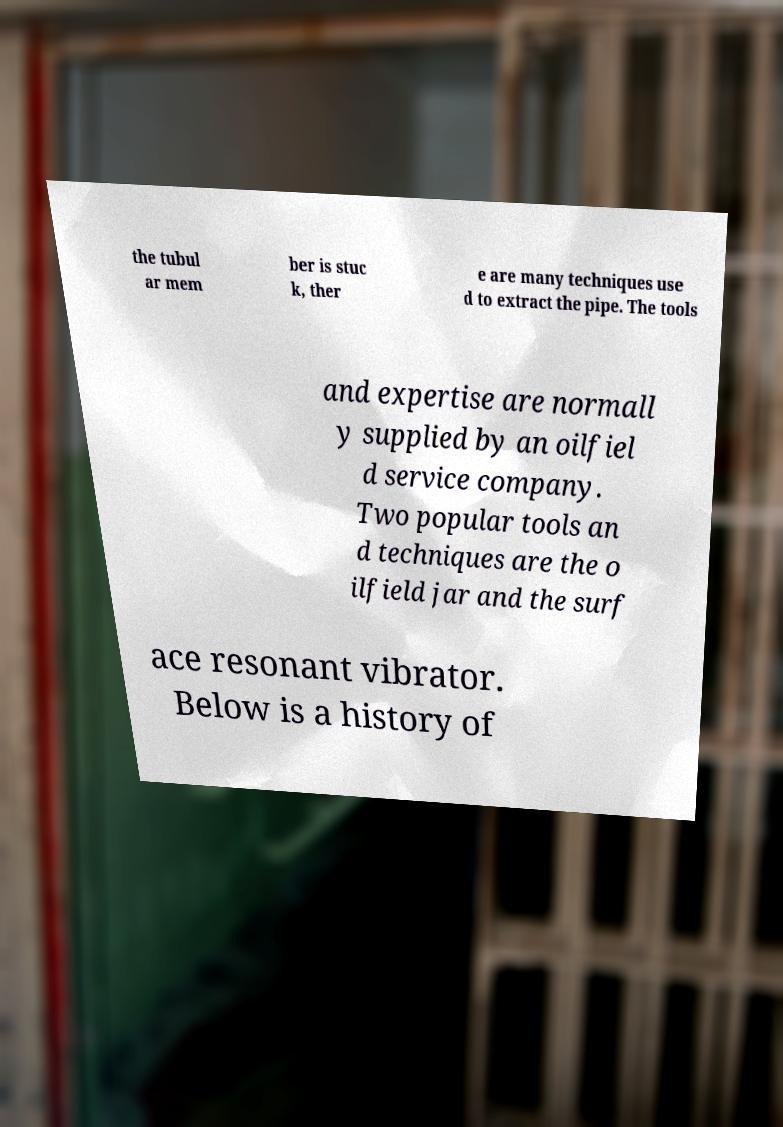For documentation purposes, I need the text within this image transcribed. Could you provide that? the tubul ar mem ber is stuc k, ther e are many techniques use d to extract the pipe. The tools and expertise are normall y supplied by an oilfiel d service company. Two popular tools an d techniques are the o ilfield jar and the surf ace resonant vibrator. Below is a history of 